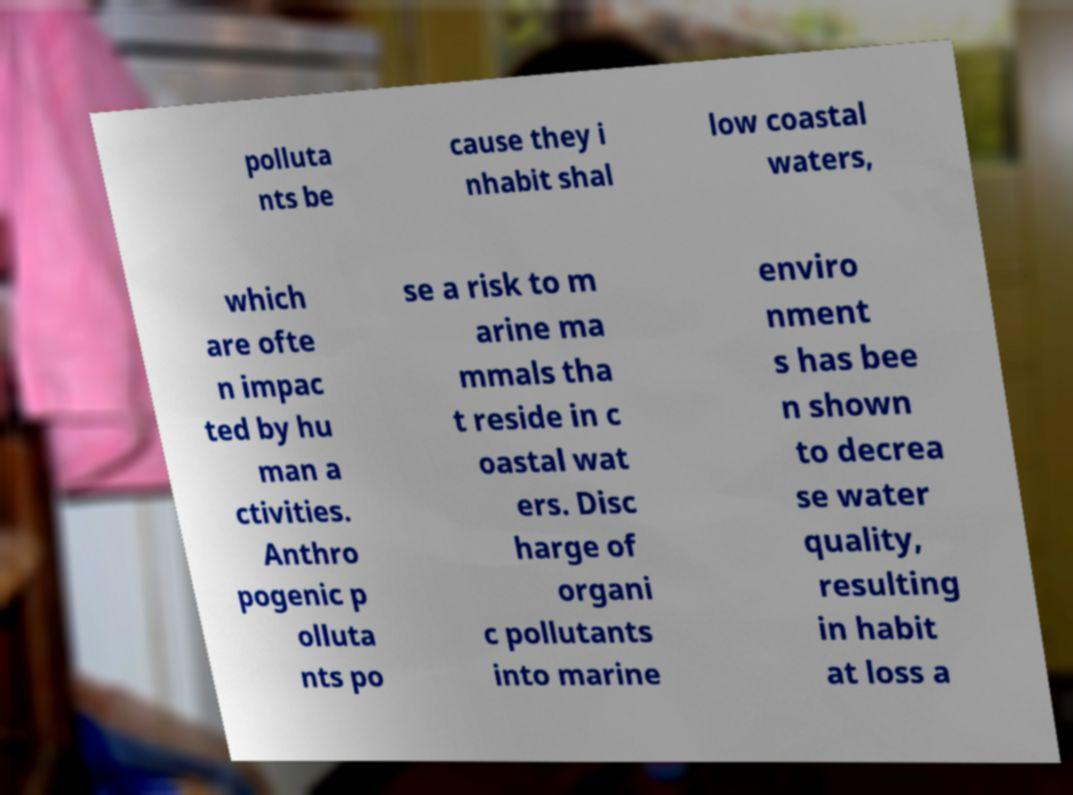I need the written content from this picture converted into text. Can you do that? polluta nts be cause they i nhabit shal low coastal waters, which are ofte n impac ted by hu man a ctivities. Anthro pogenic p olluta nts po se a risk to m arine ma mmals tha t reside in c oastal wat ers. Disc harge of organi c pollutants into marine enviro nment s has bee n shown to decrea se water quality, resulting in habit at loss a 